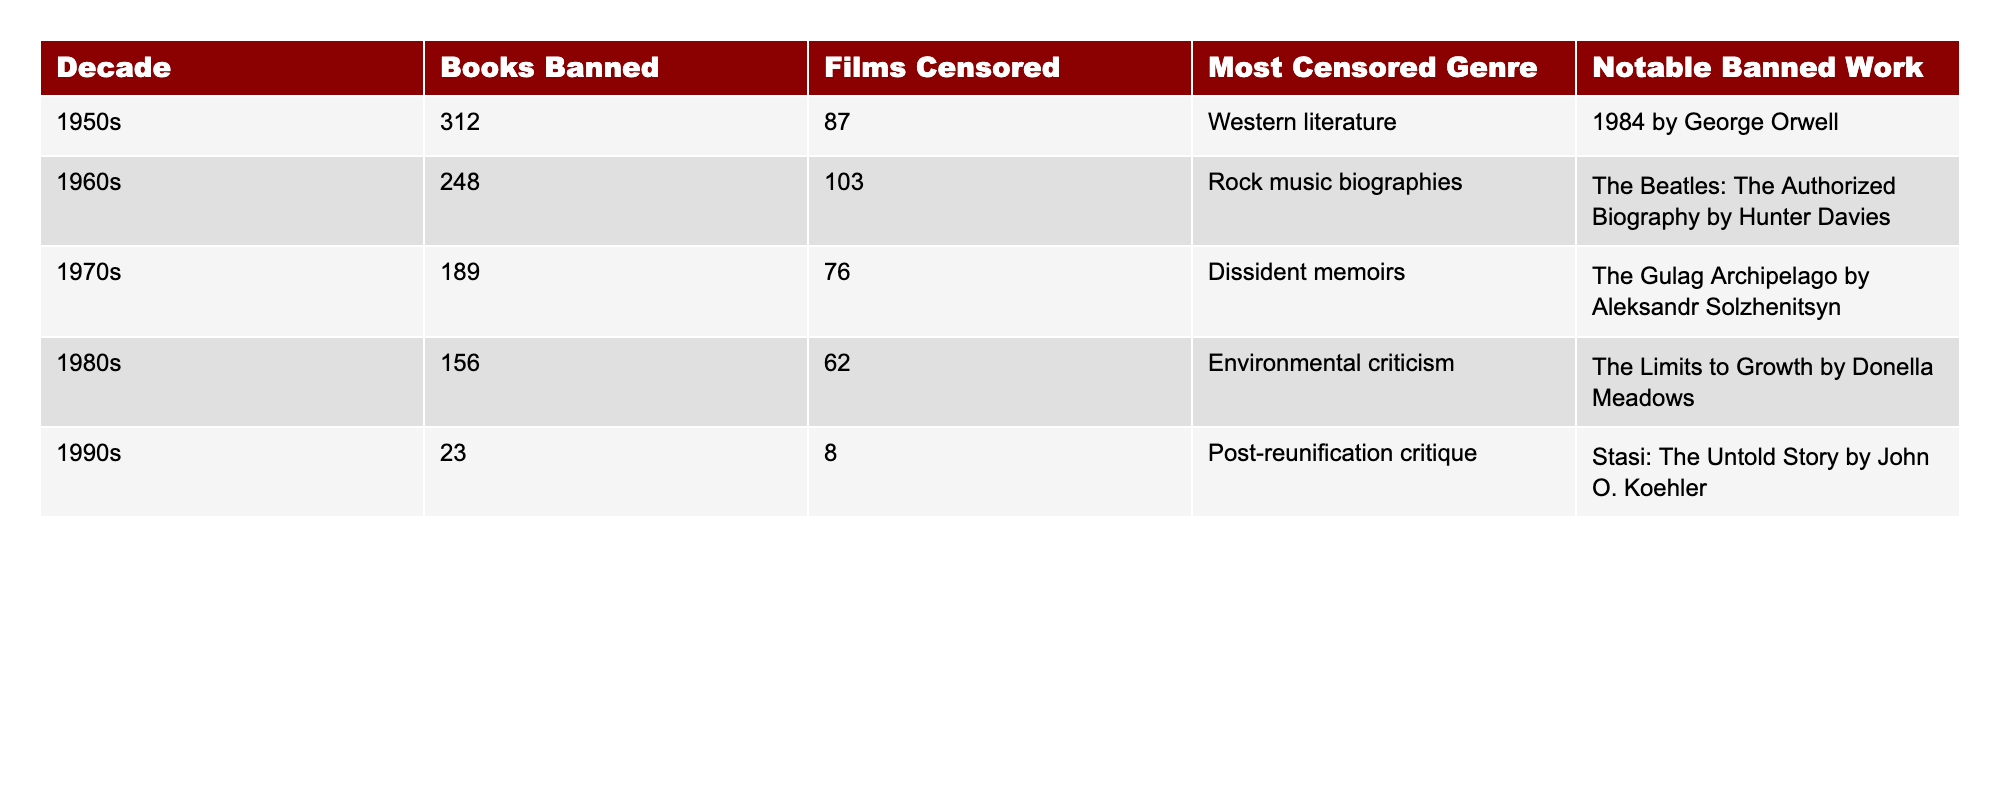What was the most banned book in the 1950s? According to the table, the most notable banned work in the 1950s was "1984 by George Orwell."
Answer: "1984 by George Orwell" How many films were censored in the 1960s? The table states that 103 films were censored in the 1960s.
Answer: 103 Which decade had the highest number of banned books? By reviewing the table, the 1950s had the highest number of banned books, with a total of 312.
Answer: 1950s What is the total number of films censored in the 1980s and 1990s combined? Adding the numbers from the table, 62 (1980s) + 8 (1990s) equals 70.
Answer: 70 Were environmental critiques censored as films in the 1980s? Yes, the most censored genre in the 1980s was environmental criticism.
Answer: Yes Did the number of banned books decrease from the 1970s to the 1990s? Yes, the number of banned books decreased from 189 (1970s) to 23 (1990s).
Answer: Yes Which genre was most commonly censored across the decades listed? The table indicates that "Western literature," "Rock music biographies," "Dissident memoirs," "Environmental criticism," and "Post-reunification critique" were the most censored genres per decade. No single genre was consistently the most censored across all decades.
Answer: No single genre In which decade was the fewest number of films censored? The table shows that in the 1990s, only 8 films were censored, which is the lowest compared to other decades.
Answer: 1990s What was the notable banned work in the 1970s? According to the table, "The Gulag Archipelago by Aleksandr Solzhenitsyn" was the notable banned work in the 1970s.
Answer: "The Gulag Archipelago by Aleksandr Solzhenitsyn" 